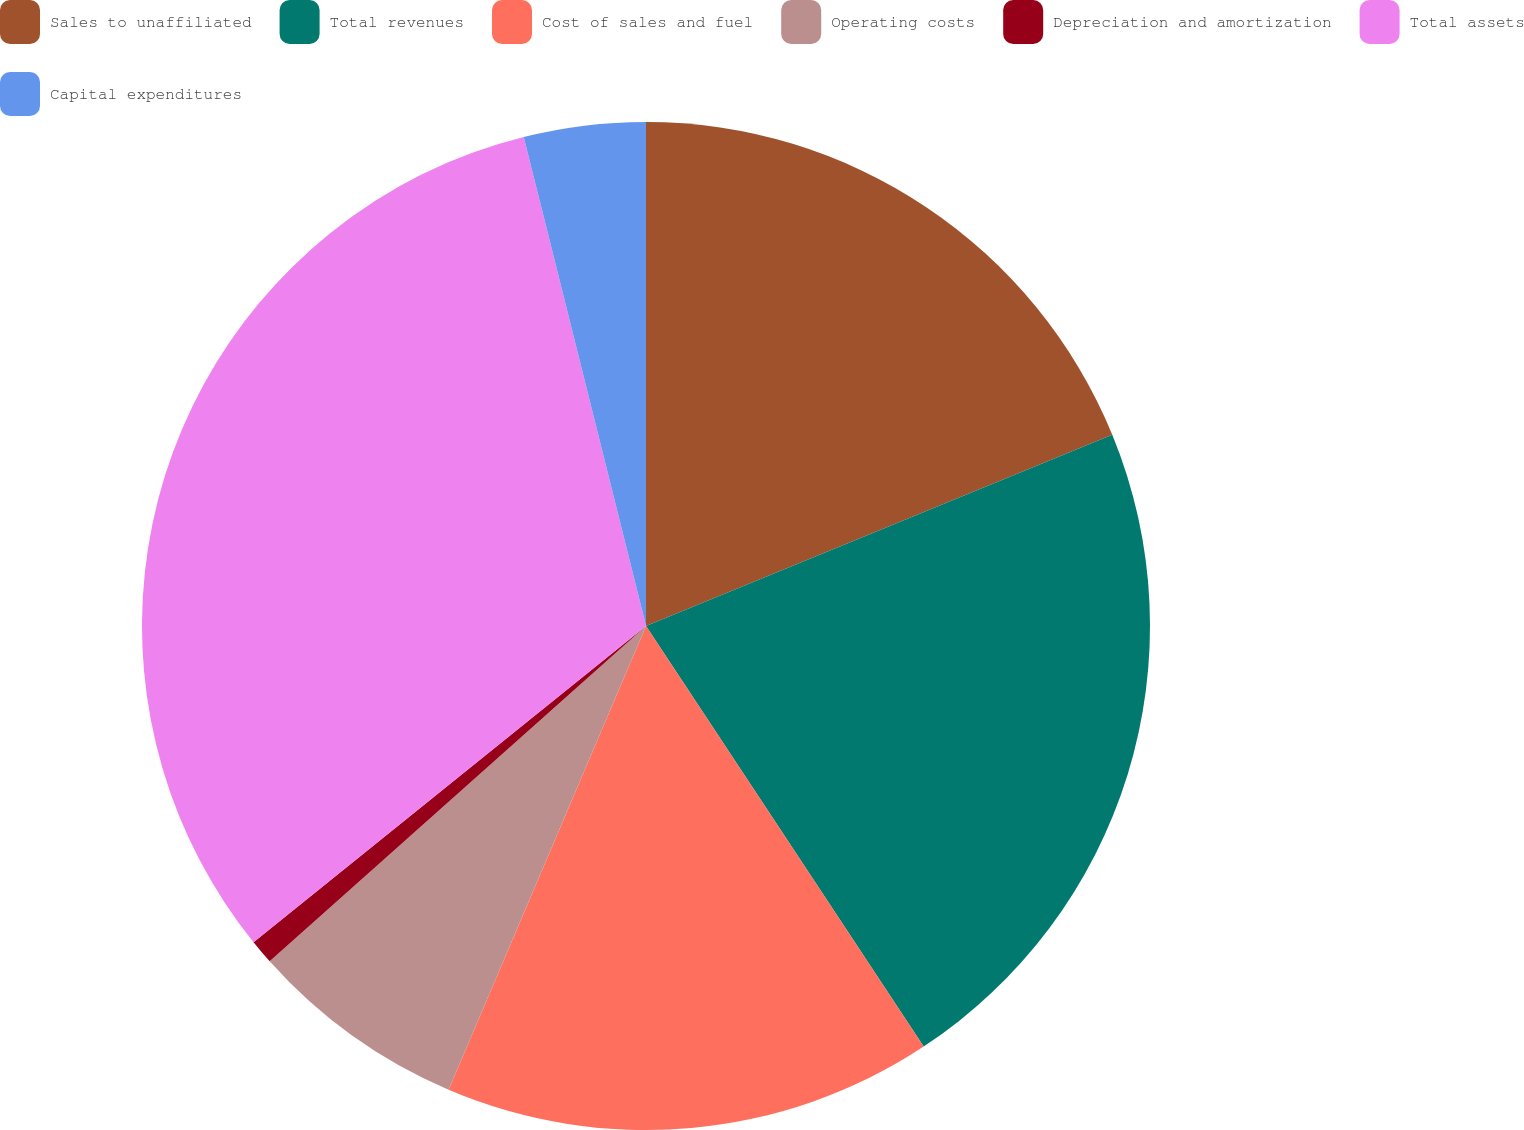<chart> <loc_0><loc_0><loc_500><loc_500><pie_chart><fcel>Sales to unaffiliated<fcel>Total revenues<fcel>Cost of sales and fuel<fcel>Operating costs<fcel>Depreciation and amortization<fcel>Total assets<fcel>Capital expenditures<nl><fcel>18.8%<fcel>21.91%<fcel>15.69%<fcel>7.01%<fcel>0.79%<fcel>31.89%<fcel>3.9%<nl></chart> 